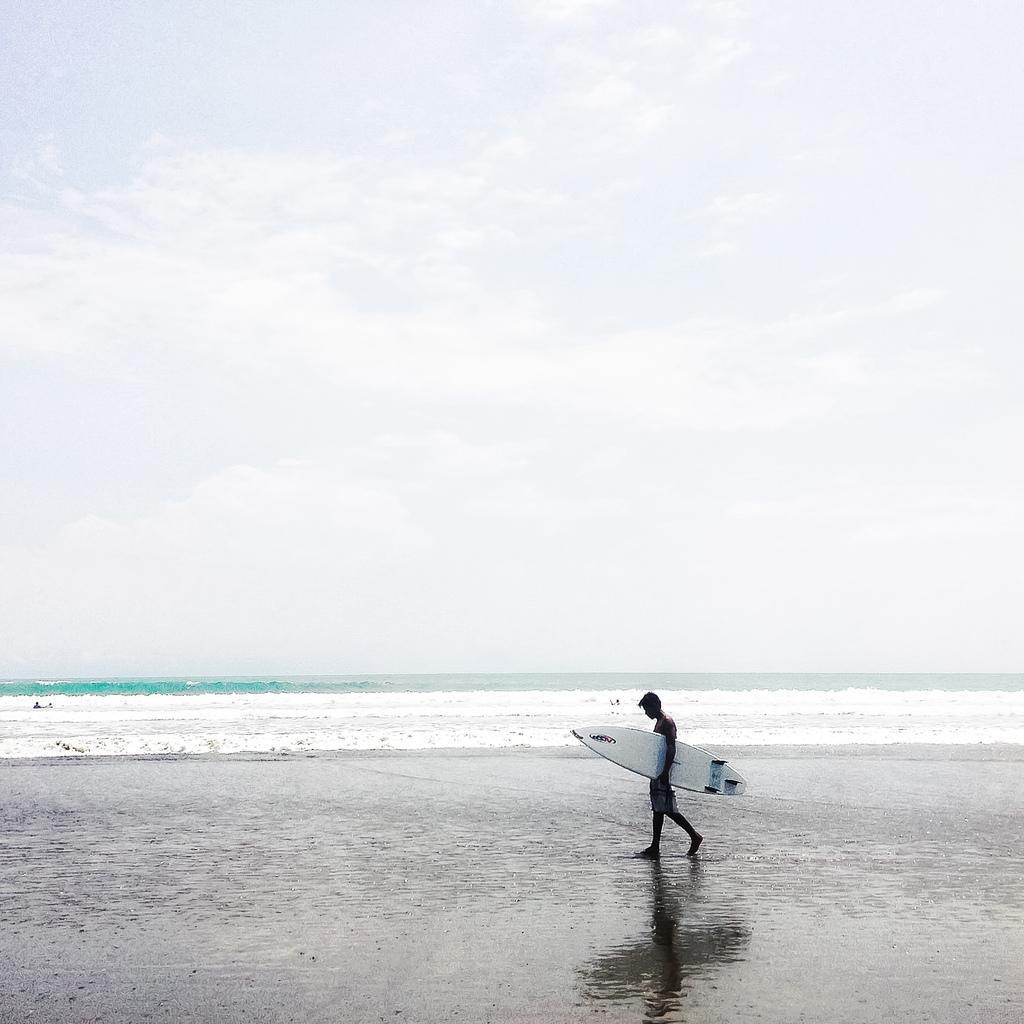Could you give a brief overview of what you see in this image? In this image the man is holding a ski board at the background we can see water and a sky. 